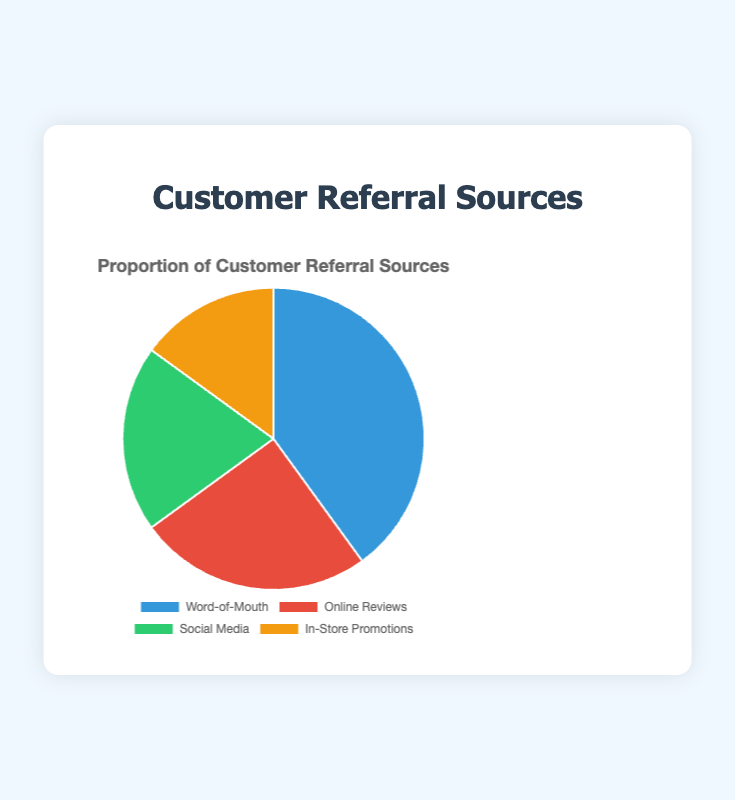What is the largest source of customer referrals? The figure shows that Word-of-Mouth has the largest slice of the pie chart. Its label indicates it represents 40% of customer referrals.
Answer: Word-of-Mouth What is the combined percentage of customer referrals from online sources? Online sources include Online Reviews and Social Media. Online Reviews contribute 25% and Social Media contributes 20%. Adding these together, 25% + 20% = 45%.
Answer: 45% Which source is represented by the green color in the pie chart? By examining the color key, the green color corresponds to Social Media, which shows a 20% share of customer referrals.
Answer: Social Media How much more percentage do Word-of-Mouth referrals contribute than Social Media referrals? Word-of-Mouth contributes 40%, while Social Media contributes 20%. The difference is 40% - 20% = 20%.
Answer: 20% Rank the customer referral sources from highest to lowest percentage. The sources and their percentages are: Word-of-Mouth (40%), Online Reviews (25%), Social Media (20%), and In-Store Promotions (15%). Sorting these in descending order gives: Word-of-Mouth, Online Reviews, Social Media, In-Store Promotions.
Answer: Word-of-Mouth, Online Reviews, Social Media, In-Store Promotions What fraction of customer referrals come from Word-of-Mouth and In-Store Promotions combined? Word-of-Mouth accounts for 40% and In-Store Promotions make up 15%. Their combined percentage is 40% + 15% = 55%, which is 55/100 or 11/20 as a fraction.
Answer: 11/20 If the total number of referrals is 500, how many referrals come from Social Media? Social Media comprises 20% of the total referrals. Therefore, the number of referrals from Social Media is 20% of 500. Calculating this gives (20/100) * 500 = 100.
Answer: 100 Which referral source has the smallest share? The smallest slice of the pie chart and its corresponding label shows In-Store Promotions have the smallest share at 15%.
Answer: In-Store Promotions How does the proportion of referrals from Online Reviews compare to In-Store Promotions? Online Reviews and In-Store Promotions have percentages of 25% and 15% respectively. Online Reviews have a higher proportion by 25% - 15% = 10%.
Answer: Online Reviews have 10% more What is the average percentage contribution of all the referral sources? The percentages are: 40%, 25%, 20%, and 15%. Adding these and dividing by the number of sources: (40 + 25 + 20 + 15) / 4 = 100 / 4 = 25%.
Answer: 25% 